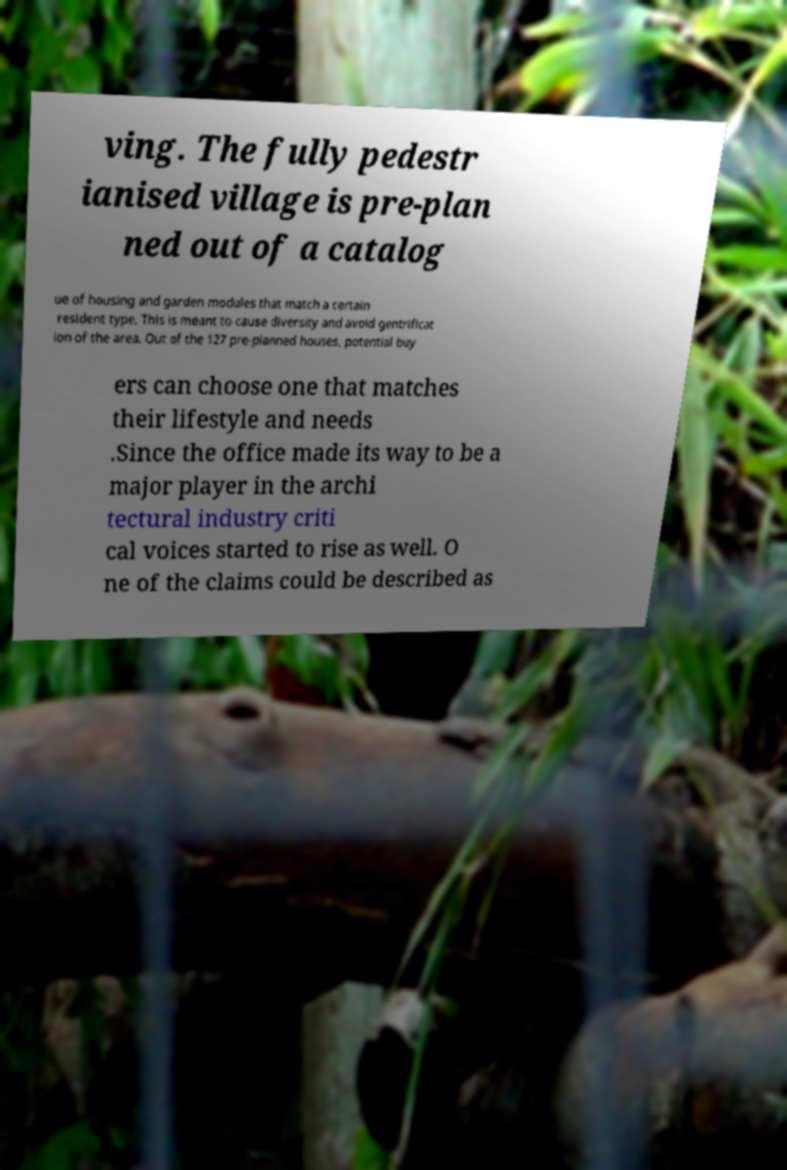Please read and relay the text visible in this image. What does it say? ving. The fully pedestr ianised village is pre-plan ned out of a catalog ue of housing and garden modules that match a certain resident type. This is meant to cause diversity and avoid gentrificat ion of the area. Out of the 127 pre-planned houses, potential buy ers can choose one that matches their lifestyle and needs .Since the office made its way to be a major player in the archi tectural industry criti cal voices started to rise as well. O ne of the claims could be described as 